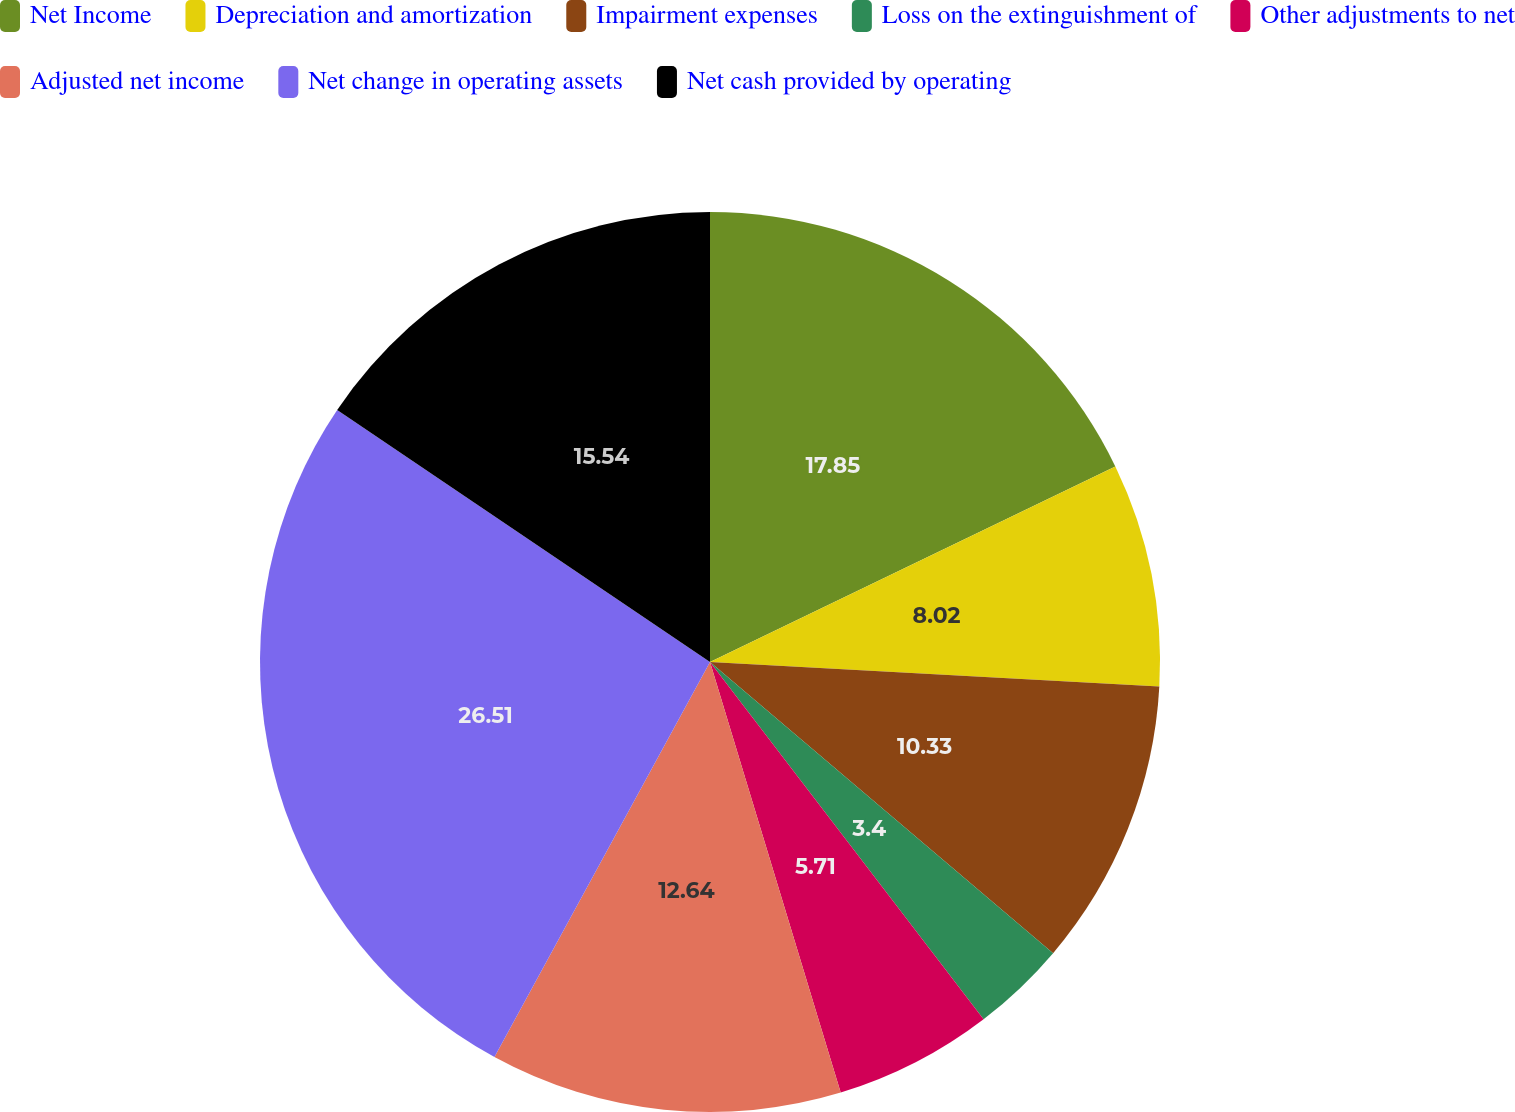Convert chart. <chart><loc_0><loc_0><loc_500><loc_500><pie_chart><fcel>Net Income<fcel>Depreciation and amortization<fcel>Impairment expenses<fcel>Loss on the extinguishment of<fcel>Other adjustments to net<fcel>Adjusted net income<fcel>Net change in operating assets<fcel>Net cash provided by operating<nl><fcel>17.85%<fcel>8.02%<fcel>10.33%<fcel>3.4%<fcel>5.71%<fcel>12.64%<fcel>26.51%<fcel>15.54%<nl></chart> 